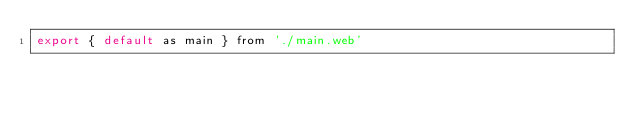Convert code to text. <code><loc_0><loc_0><loc_500><loc_500><_JavaScript_>export { default as main } from './main.web'
</code> 